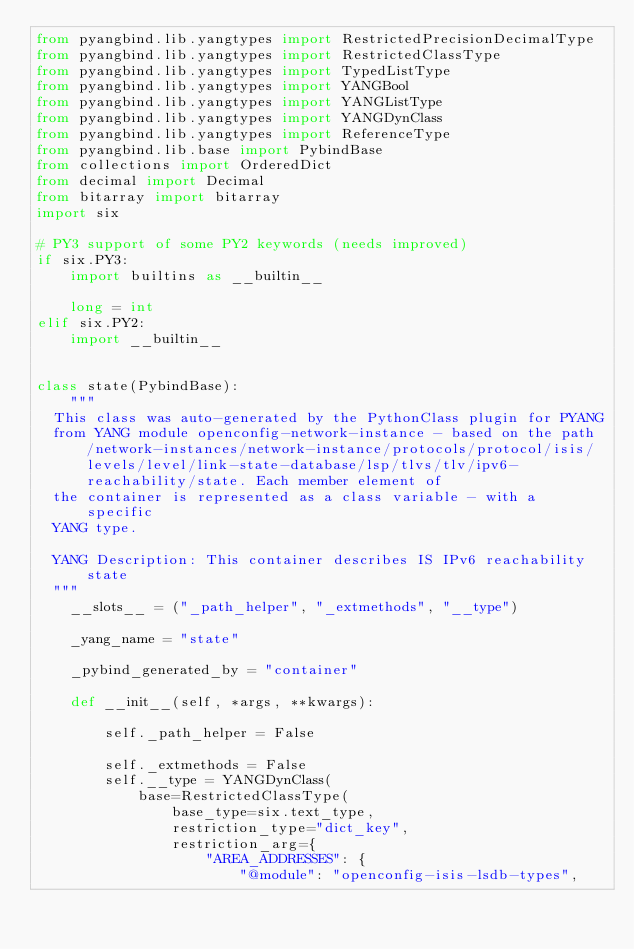<code> <loc_0><loc_0><loc_500><loc_500><_Python_>from pyangbind.lib.yangtypes import RestrictedPrecisionDecimalType
from pyangbind.lib.yangtypes import RestrictedClassType
from pyangbind.lib.yangtypes import TypedListType
from pyangbind.lib.yangtypes import YANGBool
from pyangbind.lib.yangtypes import YANGListType
from pyangbind.lib.yangtypes import YANGDynClass
from pyangbind.lib.yangtypes import ReferenceType
from pyangbind.lib.base import PybindBase
from collections import OrderedDict
from decimal import Decimal
from bitarray import bitarray
import six

# PY3 support of some PY2 keywords (needs improved)
if six.PY3:
    import builtins as __builtin__

    long = int
elif six.PY2:
    import __builtin__


class state(PybindBase):
    """
  This class was auto-generated by the PythonClass plugin for PYANG
  from YANG module openconfig-network-instance - based on the path /network-instances/network-instance/protocols/protocol/isis/levels/level/link-state-database/lsp/tlvs/tlv/ipv6-reachability/state. Each member element of
  the container is represented as a class variable - with a specific
  YANG type.

  YANG Description: This container describes IS IPv6 reachability state
  """
    __slots__ = ("_path_helper", "_extmethods", "__type")

    _yang_name = "state"

    _pybind_generated_by = "container"

    def __init__(self, *args, **kwargs):

        self._path_helper = False

        self._extmethods = False
        self.__type = YANGDynClass(
            base=RestrictedClassType(
                base_type=six.text_type,
                restriction_type="dict_key",
                restriction_arg={
                    "AREA_ADDRESSES": {
                        "@module": "openconfig-isis-lsdb-types",</code> 